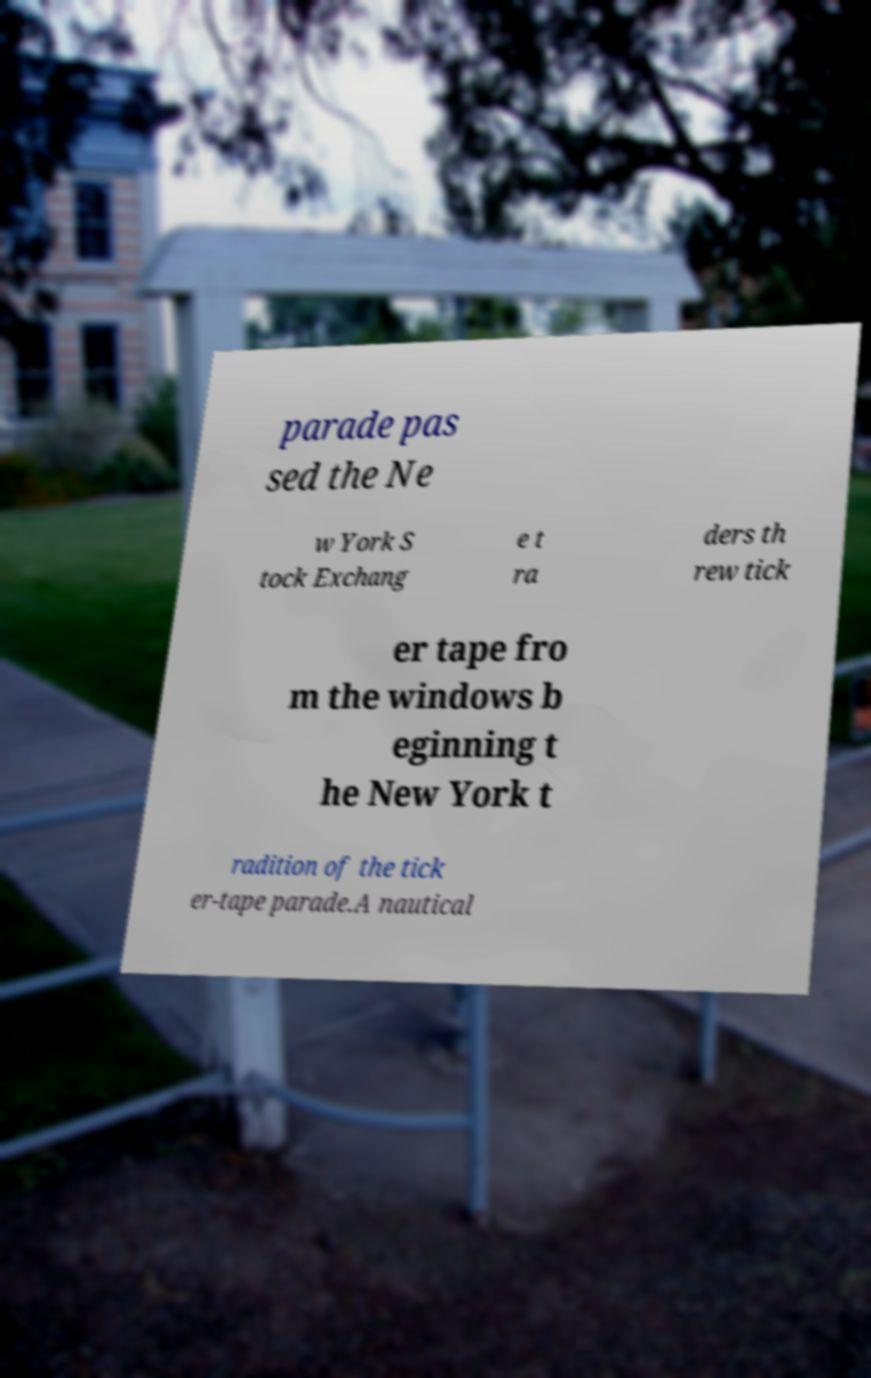There's text embedded in this image that I need extracted. Can you transcribe it verbatim? parade pas sed the Ne w York S tock Exchang e t ra ders th rew tick er tape fro m the windows b eginning t he New York t radition of the tick er-tape parade.A nautical 